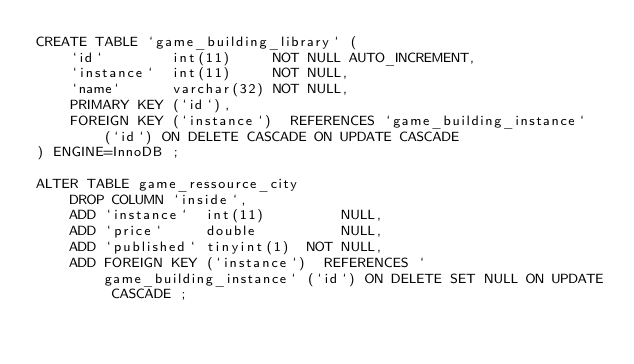Convert code to text. <code><loc_0><loc_0><loc_500><loc_500><_SQL_>CREATE TABLE `game_building_library` (
    `id`        int(11)     NOT NULL AUTO_INCREMENT,
    `instance`  int(11)     NOT NULL,
    `name`      varchar(32) NOT NULL,
    PRIMARY KEY (`id`),
    FOREIGN KEY (`instance`)  REFERENCES `game_building_instance` (`id`) ON DELETE CASCADE ON UPDATE CASCADE
) ENGINE=InnoDB ;

ALTER TABLE game_ressource_city
    DROP COLUMN `inside`,
    ADD `instance`  int(11)         NULL,
    ADD `price`     double          NULL,
    ADD `published` tinyint(1)  NOT NULL,
    ADD FOREIGN KEY (`instance`)  REFERENCES `game_building_instance` (`id`) ON DELETE SET NULL ON UPDATE CASCADE ;

</code> 